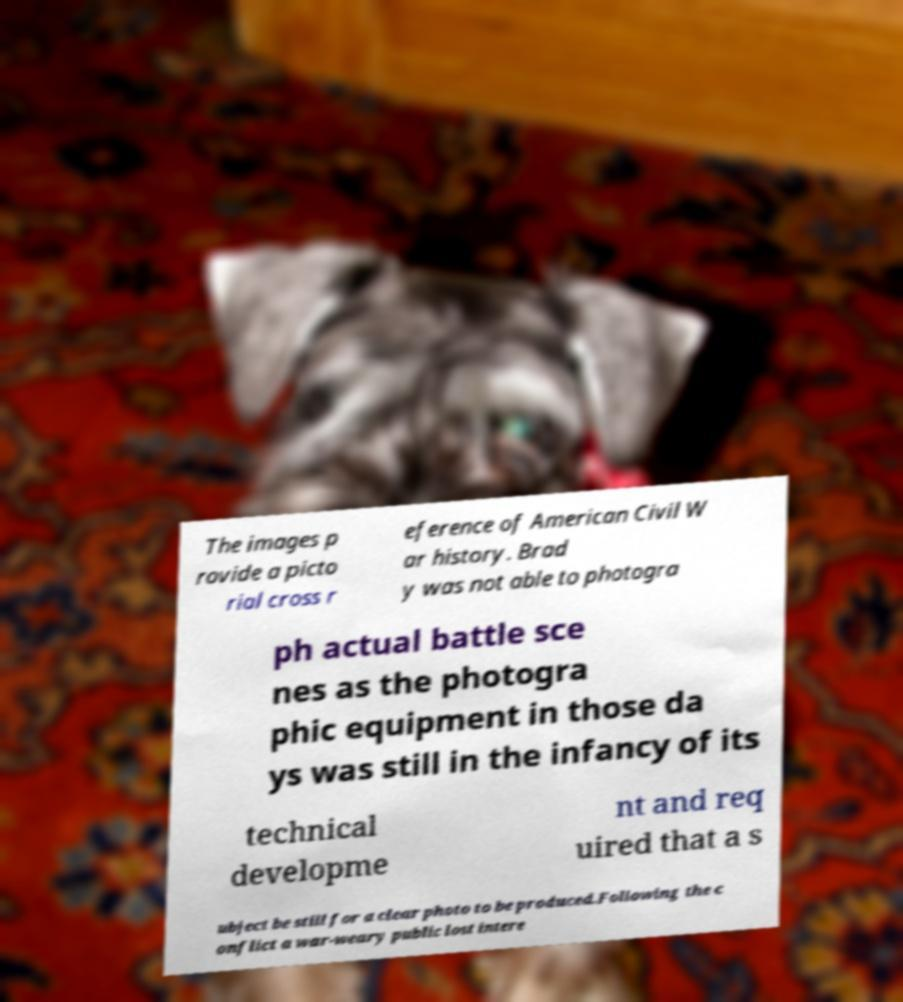I need the written content from this picture converted into text. Can you do that? The images p rovide a picto rial cross r eference of American Civil W ar history. Brad y was not able to photogra ph actual battle sce nes as the photogra phic equipment in those da ys was still in the infancy of its technical developme nt and req uired that a s ubject be still for a clear photo to be produced.Following the c onflict a war-weary public lost intere 